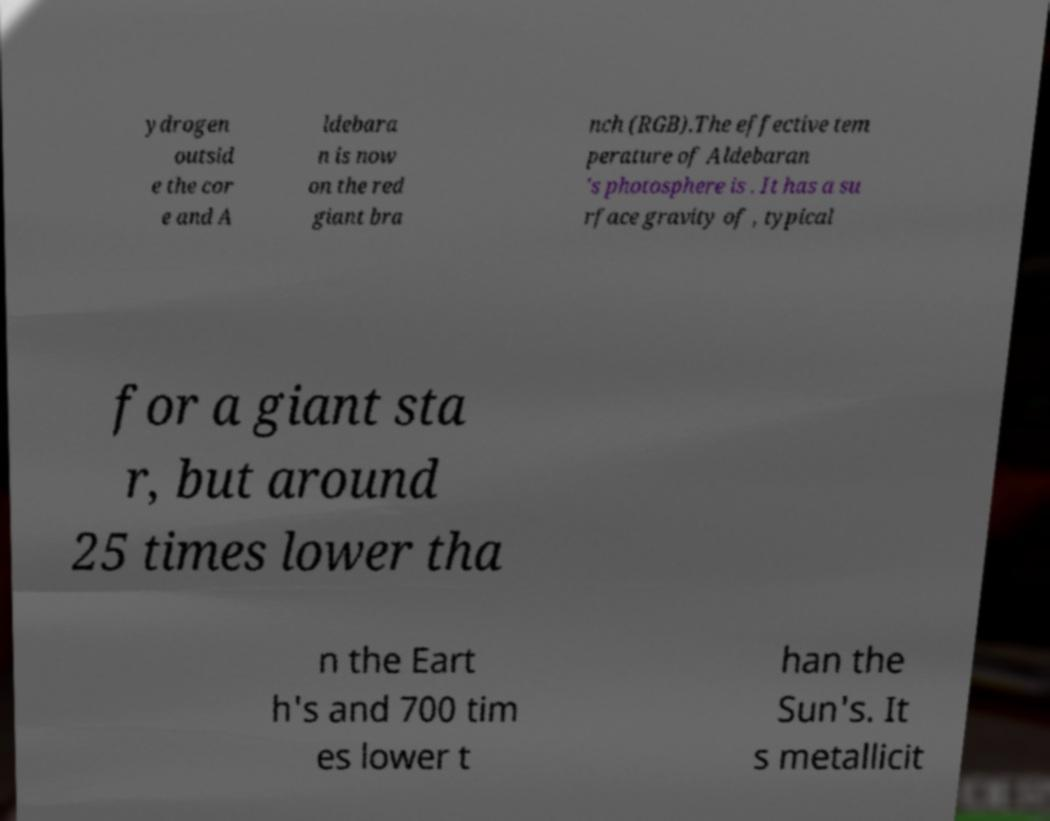Could you extract and type out the text from this image? ydrogen outsid e the cor e and A ldebara n is now on the red giant bra nch (RGB).The effective tem perature of Aldebaran 's photosphere is . It has a su rface gravity of , typical for a giant sta r, but around 25 times lower tha n the Eart h's and 700 tim es lower t han the Sun's. It s metallicit 